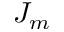<formula> <loc_0><loc_0><loc_500><loc_500>J _ { m }</formula> 